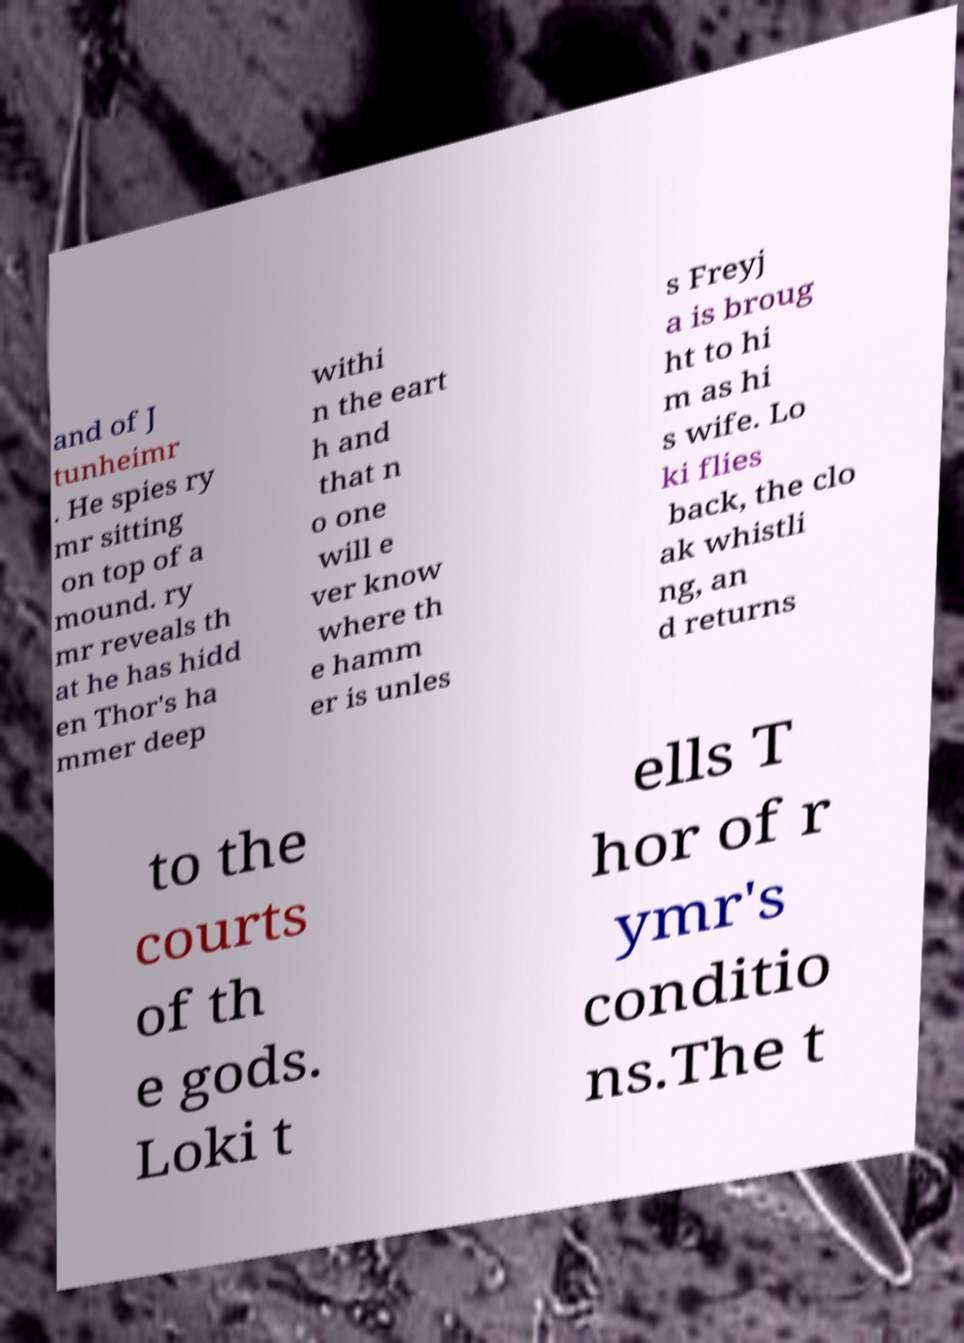Please read and relay the text visible in this image. What does it say? and of J tunheimr . He spies ry mr sitting on top of a mound. ry mr reveals th at he has hidd en Thor's ha mmer deep withi n the eart h and that n o one will e ver know where th e hamm er is unles s Freyj a is broug ht to hi m as hi s wife. Lo ki flies back, the clo ak whistli ng, an d returns to the courts of th e gods. Loki t ells T hor of r ymr's conditio ns.The t 